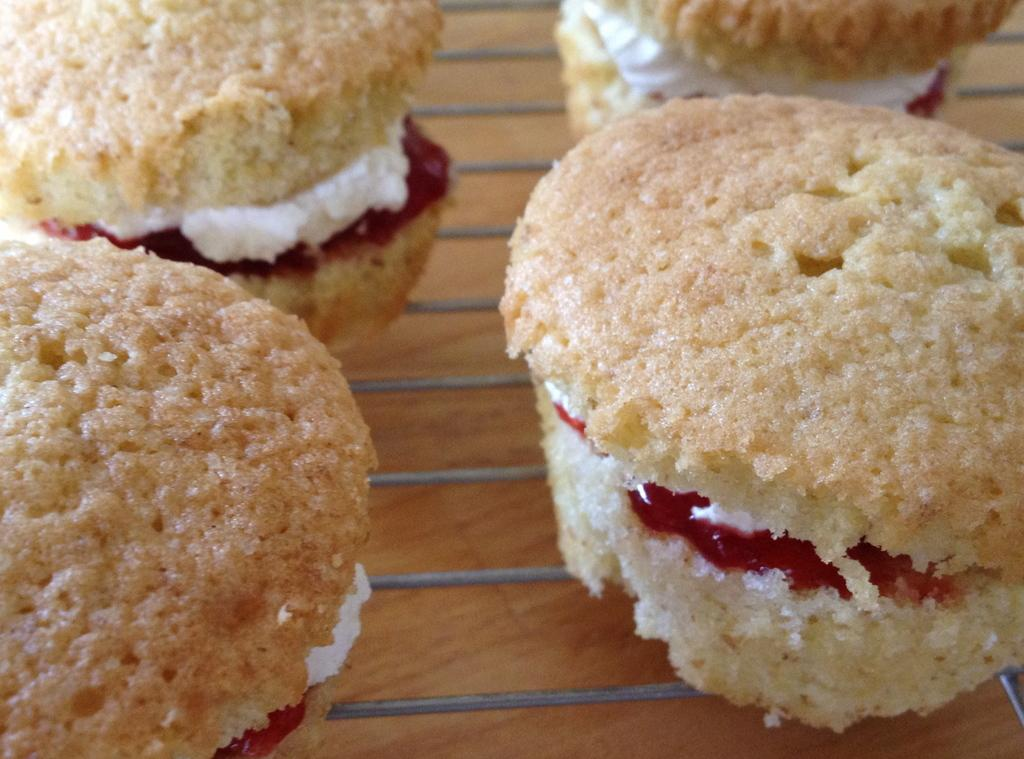What type of food can be seen in the image? There are muffins in the image. What feature can be observed at the bottom of the muffins? The muffins have grills at the bottom. What type of watch can be seen on the farm in the image? There is no watch or farm present in the image; it only features muffins with grills at the bottom. What type of soda is being served with the muffins in the image? There is no soda or indication of any beverage in the image; it only features muffins with grills at the bottom. 